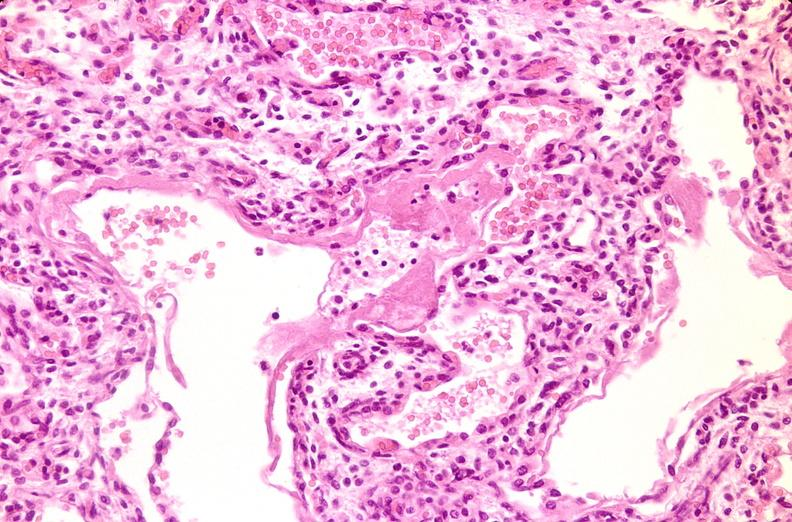where is this?
Answer the question using a single word or phrase. Lung 